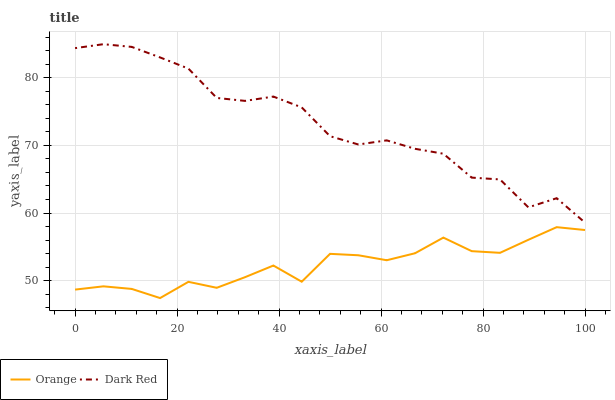Does Orange have the minimum area under the curve?
Answer yes or no. Yes. Does Dark Red have the maximum area under the curve?
Answer yes or no. Yes. Does Dark Red have the minimum area under the curve?
Answer yes or no. No. Is Orange the smoothest?
Answer yes or no. Yes. Is Dark Red the roughest?
Answer yes or no. Yes. Is Dark Red the smoothest?
Answer yes or no. No. Does Dark Red have the lowest value?
Answer yes or no. No. Does Dark Red have the highest value?
Answer yes or no. Yes. Is Orange less than Dark Red?
Answer yes or no. Yes. Is Dark Red greater than Orange?
Answer yes or no. Yes. Does Orange intersect Dark Red?
Answer yes or no. No. 